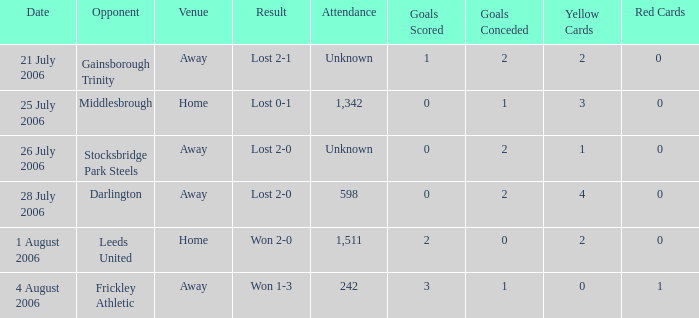What is the attendance rate for the Middlesbrough opponent? 1342.0. 